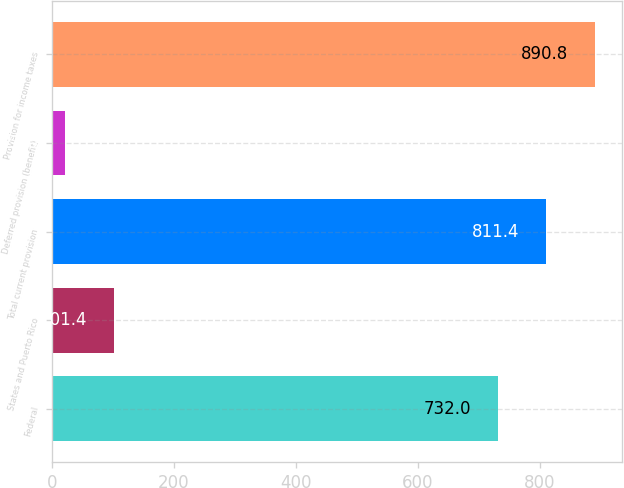<chart> <loc_0><loc_0><loc_500><loc_500><bar_chart><fcel>Federal<fcel>States and Puerto Rico<fcel>Total current provision<fcel>Deferred provision (benefit)<fcel>Provision for income taxes<nl><fcel>732<fcel>101.4<fcel>811.4<fcel>22<fcel>890.8<nl></chart> 